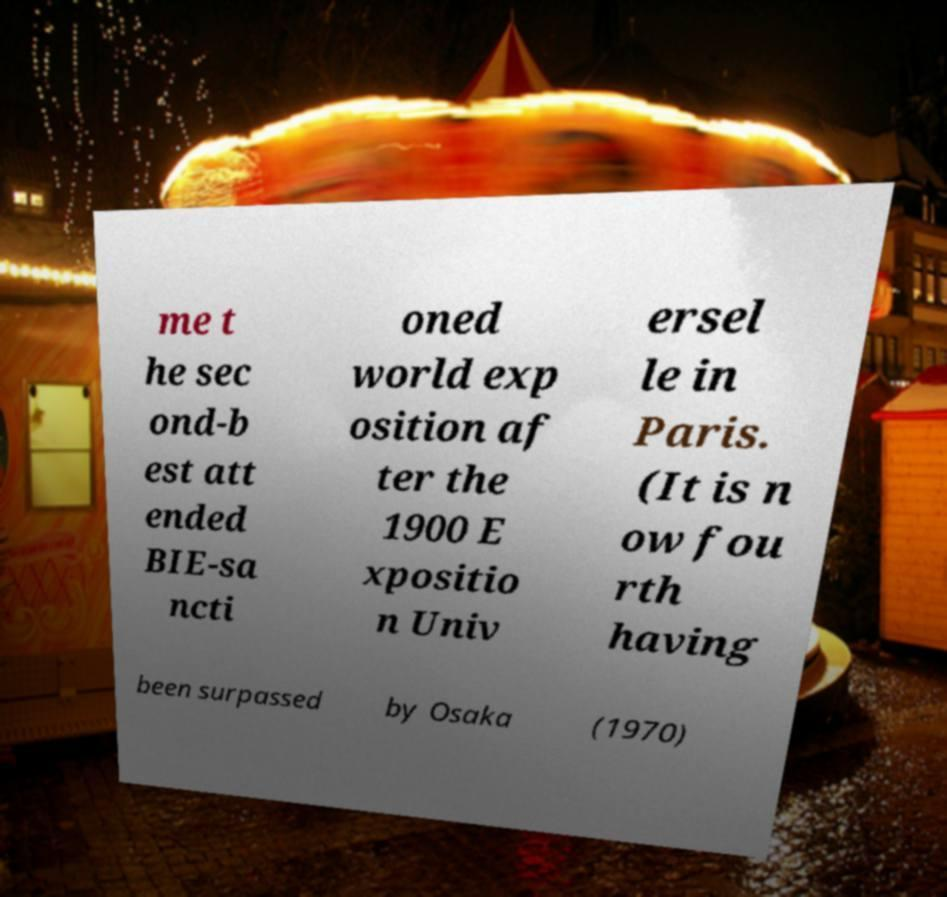Can you read and provide the text displayed in the image?This photo seems to have some interesting text. Can you extract and type it out for me? me t he sec ond-b est att ended BIE-sa ncti oned world exp osition af ter the 1900 E xpositio n Univ ersel le in Paris. (It is n ow fou rth having been surpassed by Osaka (1970) 